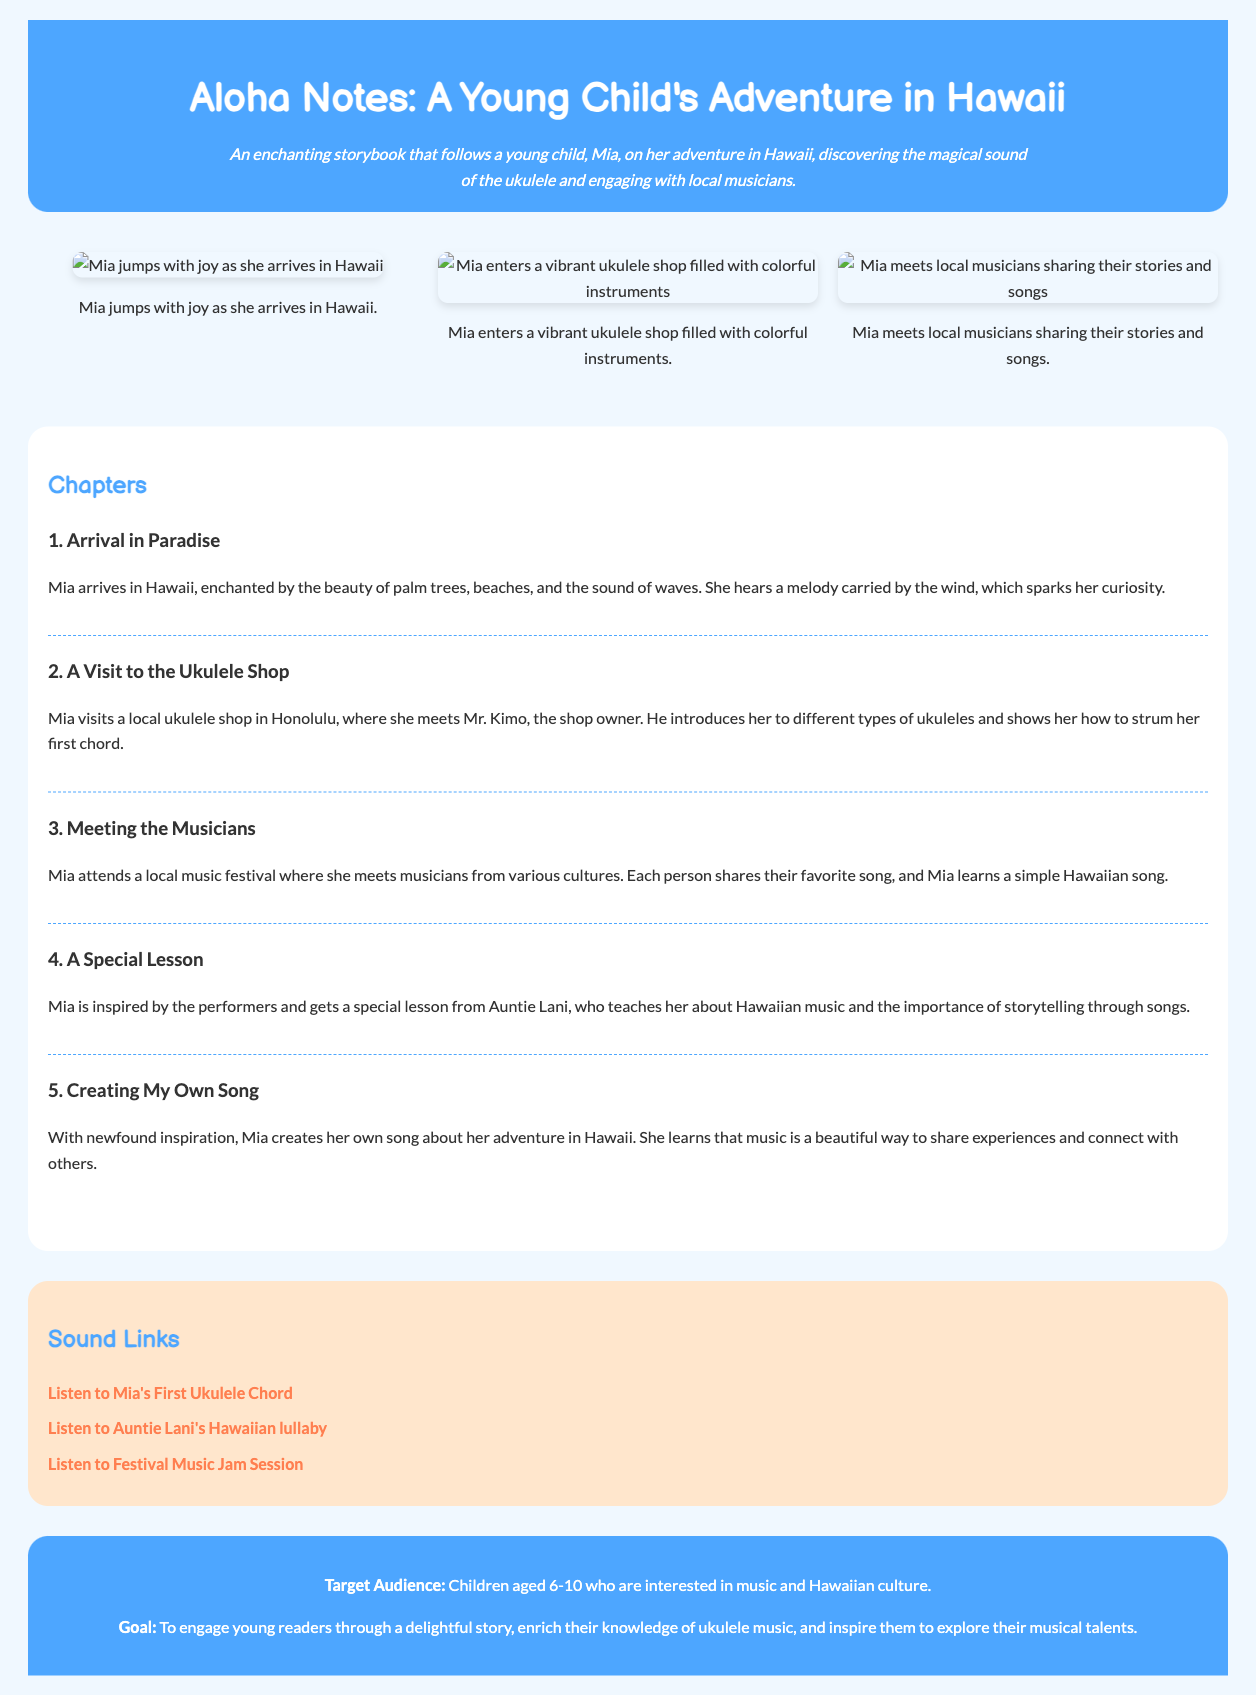What is the title of the storybook? The title of the storybook is mentioned in the header of the document.
Answer: Aloha Notes: A Young Child's Adventure in Hawaii Who is the main character of the story? The main character, Mia, is introduced in the description of the storybook.
Answer: Mia What is the first chapter about? The first chapter describes the arrival of Mia in Hawaii.
Answer: Arrival in Paradise What type of shop does Mia visit? The document states that Mia visits a local ukulele shop in Honolulu.
Answer: Ukulele shop Who teaches Mia about Hawaiian music? Auntie Lani is the character who teaches Mia about Hawaiian music.
Answer: Auntie Lani How many chapters are in the storybook? The total number of chapters is listed in the chapters section of the document.
Answer: Five What emotion does Mia show when she arrives in Hawaii? The document describes Mia jumping with joy upon arriving in Hawaii.
Answer: Joy What is the target audience of the storybook? The target audience is clearly stated in the footer of the document.
Answer: Children aged 6-10 What type of music does Mia learn to play? The storybook revolves around Mia learning to play a specific type of instrument.
Answer: Ukulele 